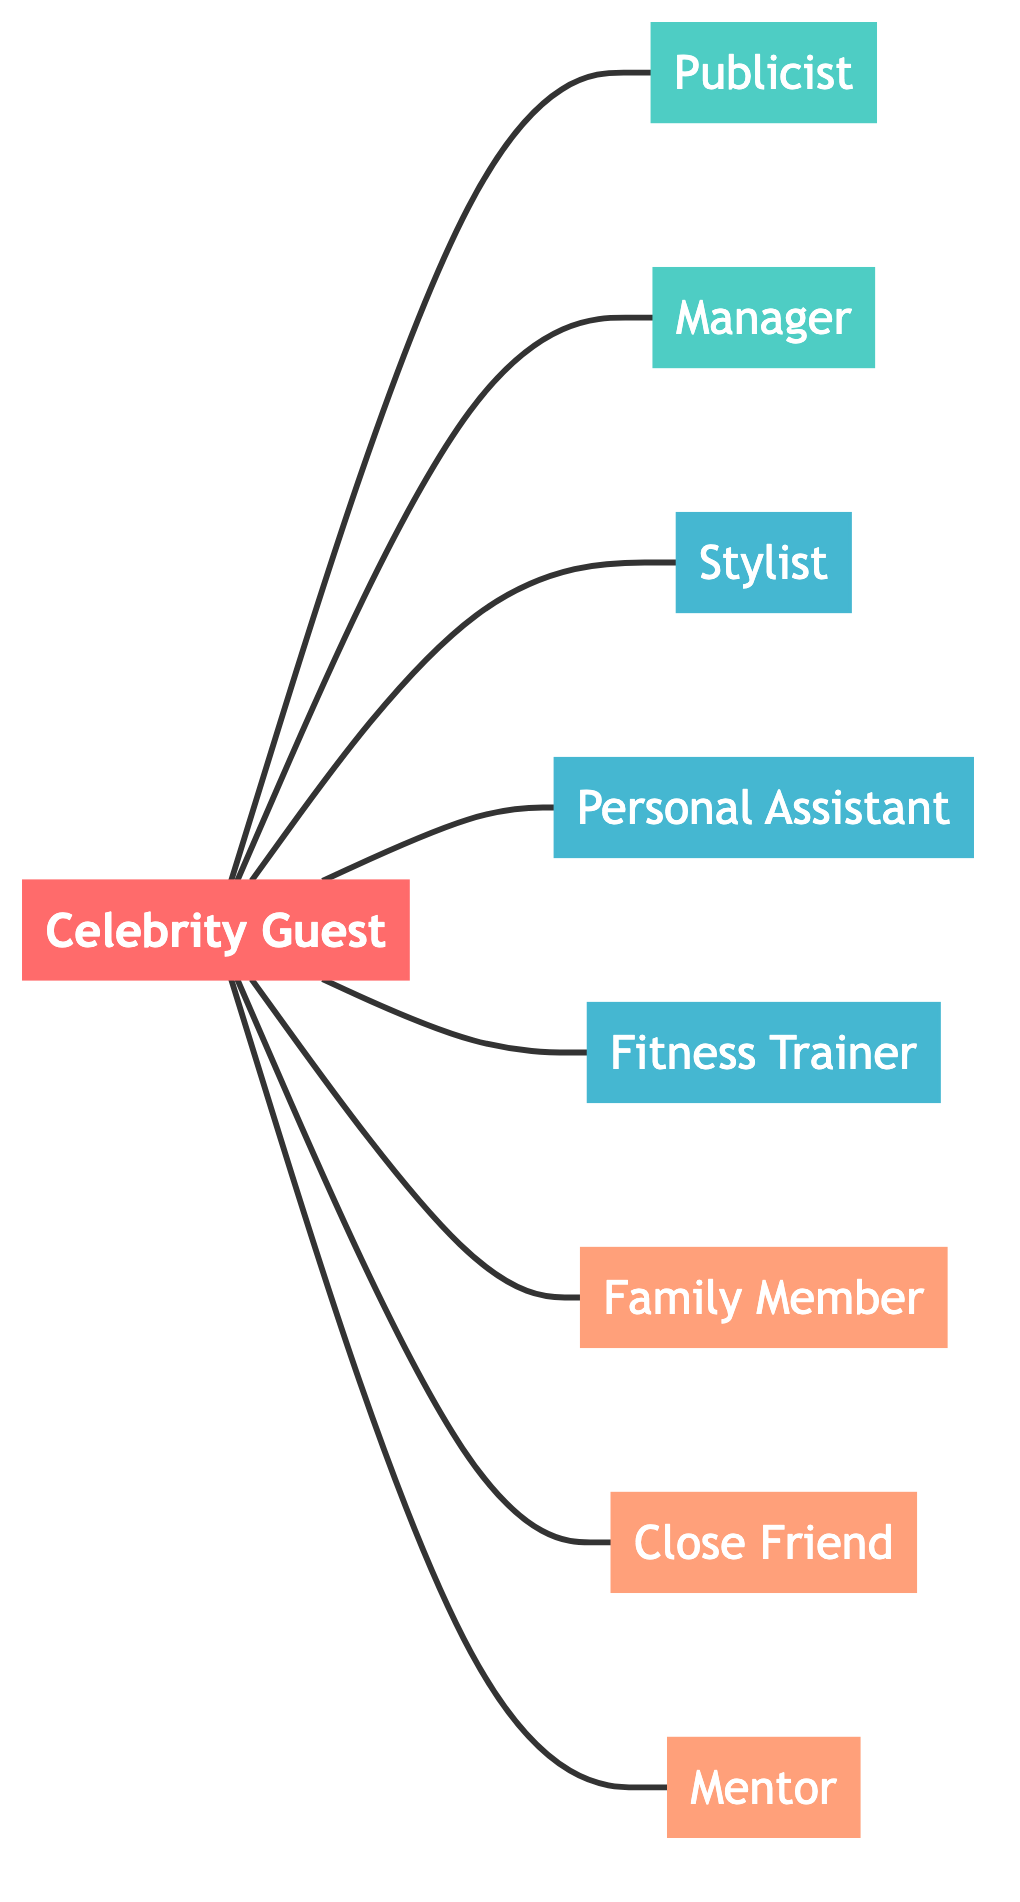What is the total number of nodes in the network? The network consists of all unique entities including the central figure and all connections. Counting these, there are 9 nodes: Celebrity Guest, Publicist, Manager, Stylist, Personal Assistant, Fitness Trainer, Family Member, Close Friend, and Mentor.
Answer: 9 Which node represents the personal assistant? In the diagram, the node labeled "Personal Assistant" represents this role. It is connected to the central node, indicating its position in the support system.
Answer: Personal Assistant How many types of personal influences are represented in the diagram? The diagram shows personal influences as nodes and identifies three: Family Member, Close Friend, and Mentor. Thus, there are a total of three nodes classified as personal influences.
Answer: 3 Is the stylist considered an advisor in the network? The diagram separates nodes based on their roles. The Stylist is classified under the team category, while advisors are linked to the type category. Therefore, the Stylist is not an advisor.
Answer: No Who is connected to the celebrity guest along with the publicist? In the diagram, both the Manager and Publicist are directly connected to the Celebrity Guest, indicating they are part of the same support system. The relationships can be observed visually by tracing the links.
Answer: Manager What color represents the advisor nodes in the diagram? The color coding in the diagram clearly indicates that advisor nodes are filled with a teal color. This visual representation allows quick identification of the roles in the network.
Answer: Teal Which personal influence is listed first in the diagram? The nodes are arranged in a way that the Family Member appears first among the personal influences connected to the Celebrity Guest. This positional order reflects their proximity in the support system.
Answer: Family Member How many teams are represented in the diagram? The diagram identifies three team roles connected to the Celebrity Guest: Stylist, Personal Assistant, and Fitness Trainer. By counting these connections, we confirm that there are three team members.
Answer: 3 What role does the Celebrity Guest play in the network? The Celebrity Guest is the central node, from which all other connections branch out, signifying its pivotal role in the support system. Therefore, it serves as the centerpiece of the network.
Answer: Central node 